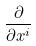Convert formula to latex. <formula><loc_0><loc_0><loc_500><loc_500>\frac { \partial } { \partial x ^ { i } }</formula> 